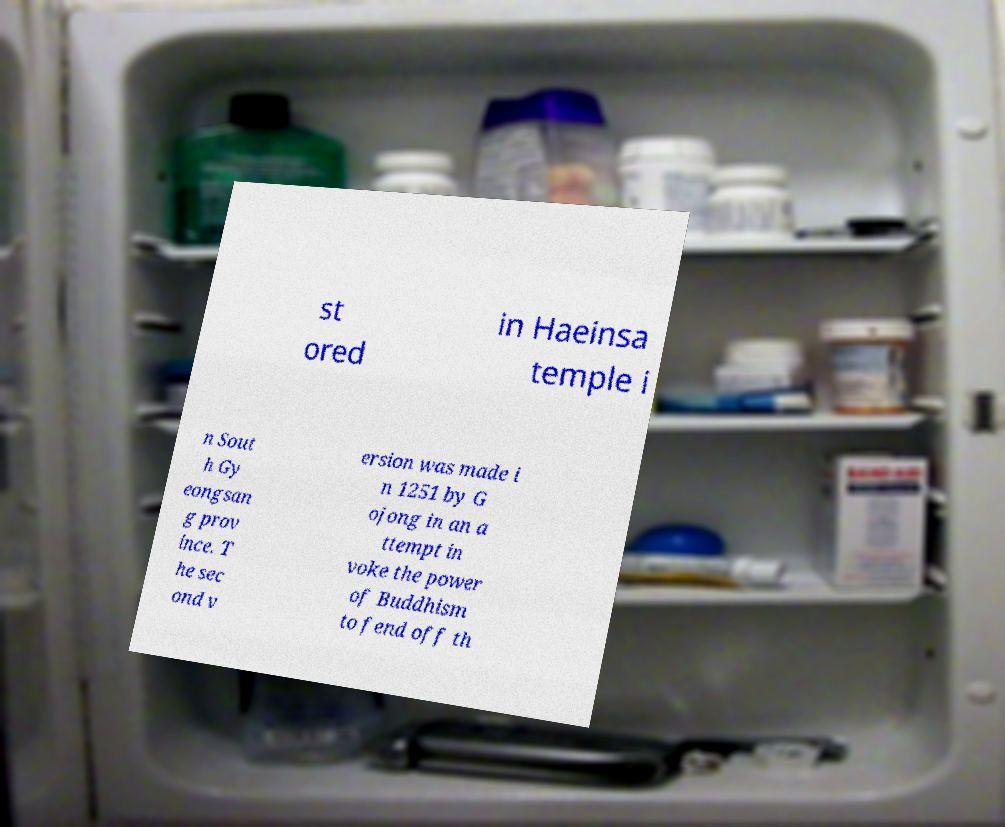Please identify and transcribe the text found in this image. st ored in Haeinsa temple i n Sout h Gy eongsan g prov ince. T he sec ond v ersion was made i n 1251 by G ojong in an a ttempt in voke the power of Buddhism to fend off th 